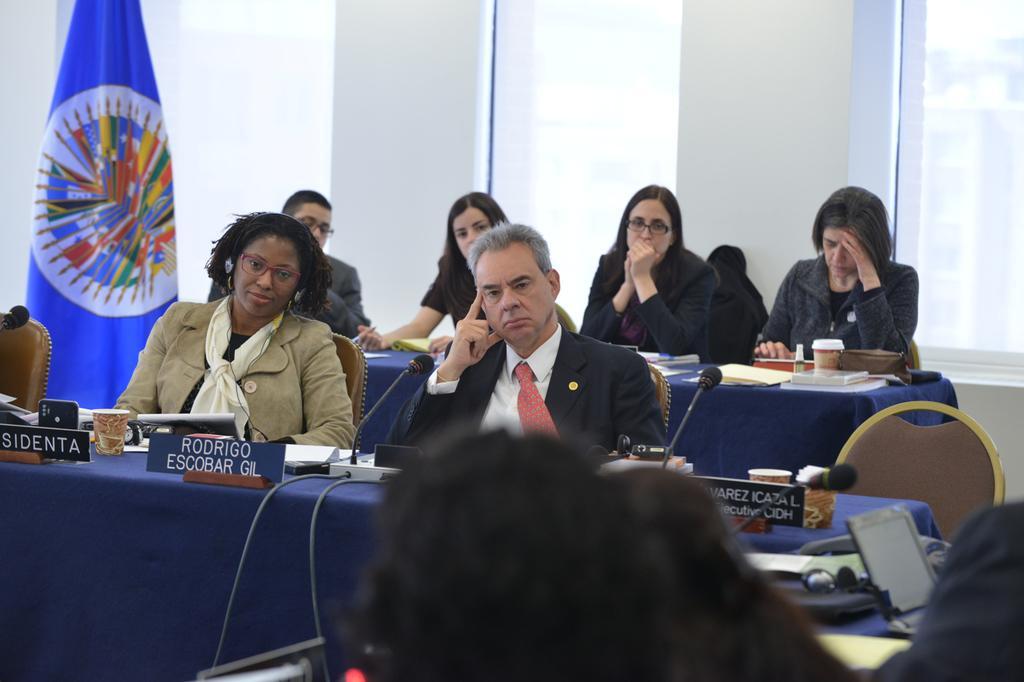Please provide a concise description of this image. people are seated and they are wearing suit. There are blue tables on which there are microphones, wires, name plates and glasses. There is a blue flag at the left. 